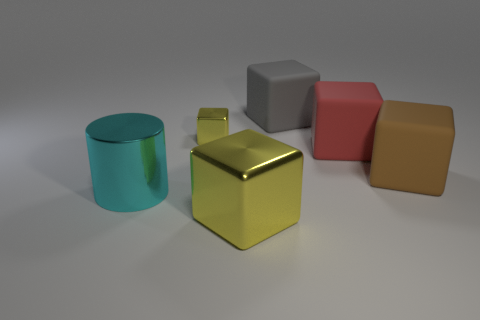How would you describe the various materials of the objects in the image? The image showcases objects made of different materials. The cylindrical object appears to be made of glass with a glossy teal finish. The middle object on the front has a metallic sheen, possibly steel, painted yellow. The remaining objects might be made of matte plastic or rubber, as suggested by their soft, non-reflective surfaces and colors such as grey, red, and brown. 